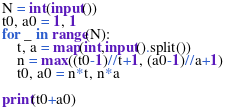<code> <loc_0><loc_0><loc_500><loc_500><_Python_>N = int(input())
t0, a0 = 1, 1
for _ in range(N):
    t, a = map(int,input().split())
    n = max((t0-1)//t+1, (a0-1)//a+1)
    t0, a0 = n*t, n*a

print(t0+a0)
</code> 